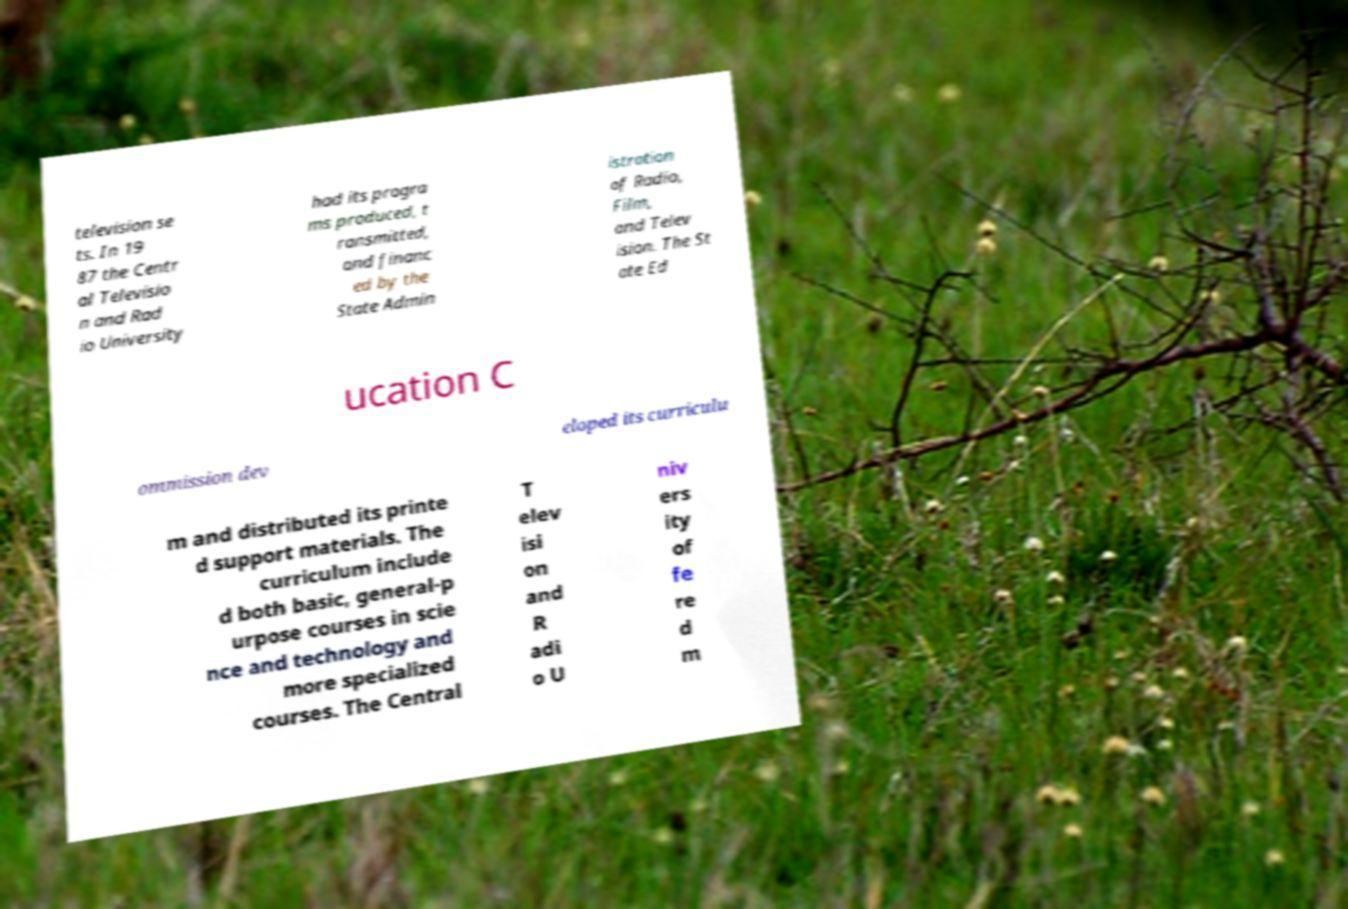I need the written content from this picture converted into text. Can you do that? television se ts. In 19 87 the Centr al Televisio n and Rad io University had its progra ms produced, t ransmitted, and financ ed by the State Admin istration of Radio, Film, and Telev ision. The St ate Ed ucation C ommission dev eloped its curriculu m and distributed its printe d support materials. The curriculum include d both basic, general-p urpose courses in scie nce and technology and more specialized courses. The Central T elev isi on and R adi o U niv ers ity of fe re d m 